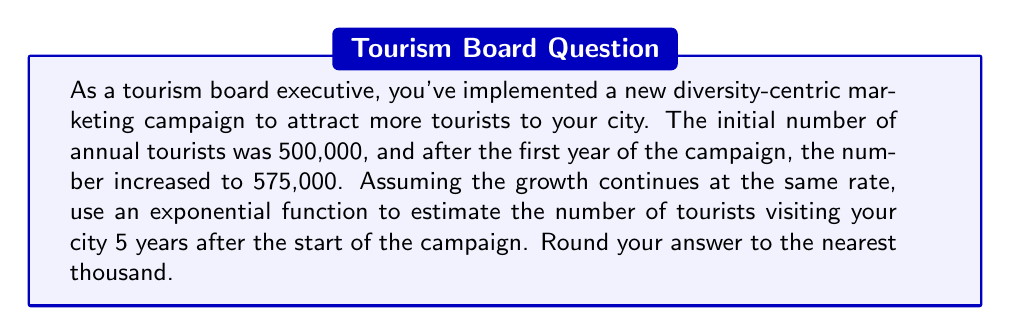Show me your answer to this math problem. To solve this problem, we need to use an exponential growth function in the form:

$$A(t) = A_0 \cdot (1 + r)^t$$

Where:
$A(t)$ is the number of tourists after $t$ years
$A_0$ is the initial number of tourists
$r$ is the annual growth rate
$t$ is the number of years

Step 1: Calculate the growth rate $(r)$
We know that after one year, the number of tourists increased from 500,000 to 575,000.
$$575,000 = 500,000 \cdot (1 + r)^1$$

Solving for $r$:
$$\frac{575,000}{500,000} = 1 + r$$
$$1.15 = 1 + r$$
$$r = 0.15 = 15\%$$

Step 2: Set up the exponential function
$$A(t) = 500,000 \cdot (1 + 0.15)^t$$

Step 3: Calculate the number of tourists after 5 years
$$A(5) = 500,000 \cdot (1.15)^5$$

Step 4: Evaluate the expression
$$A(5) = 500,000 \cdot 2.0113689$$
$$A(5) = 1,005,684.45$$

Step 5: Round to the nearest thousand
$$A(5) \approx 1,006,000$$
Answer: Approximately 1,006,000 tourists 